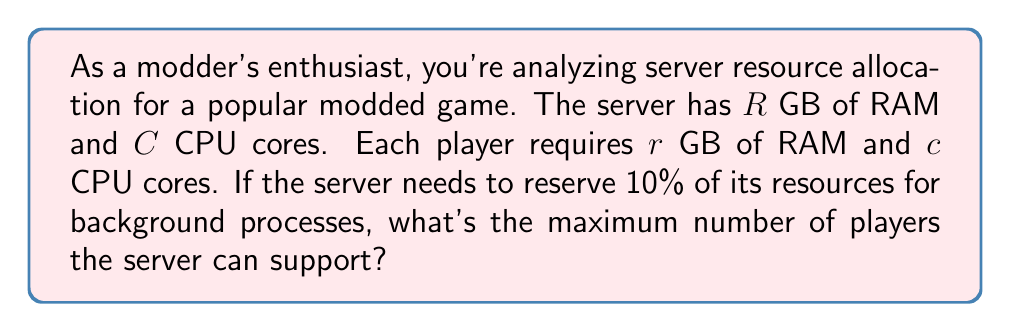Show me your answer to this math problem. Let's approach this step-by-step:

1) First, we need to calculate the available resources after reserving 10% for background processes:
   Available RAM: $R_{avail} = 0.9R$ GB
   Available CPU cores: $C_{avail} = 0.9C$ cores

2) Now, we can calculate the number of players that can be supported based on RAM:
   $P_{RAM} = \left\lfloor\frac{R_{avail}}{r}\right\rfloor = \left\lfloor\frac{0.9R}{r}\right\rfloor$

3) Similarly, we can calculate the number of players that can be supported based on CPU cores:
   $P_{CPU} = \left\lfloor\frac{C_{avail}}{c}\right\rfloor = \left\lfloor\frac{0.9C}{c}\right\rfloor$

4) The maximum number of players the server can support is the minimum of these two values:
   $P_{max} = \min(P_{RAM}, P_{CPU})$

5) Therefore, the final formula for the maximum number of players is:
   $$P_{max} = \min\left(\left\lfloor\frac{0.9R}{r}\right\rfloor, \left\lfloor\frac{0.9C}{c}\right\rfloor\right)$$

Where $\lfloor \rfloor$ represents the floor function (rounding down to the nearest integer).
Answer: $\min\left(\left\lfloor\frac{0.9R}{r}\right\rfloor, \left\lfloor\frac{0.9C}{c}\right\rfloor\right)$ 